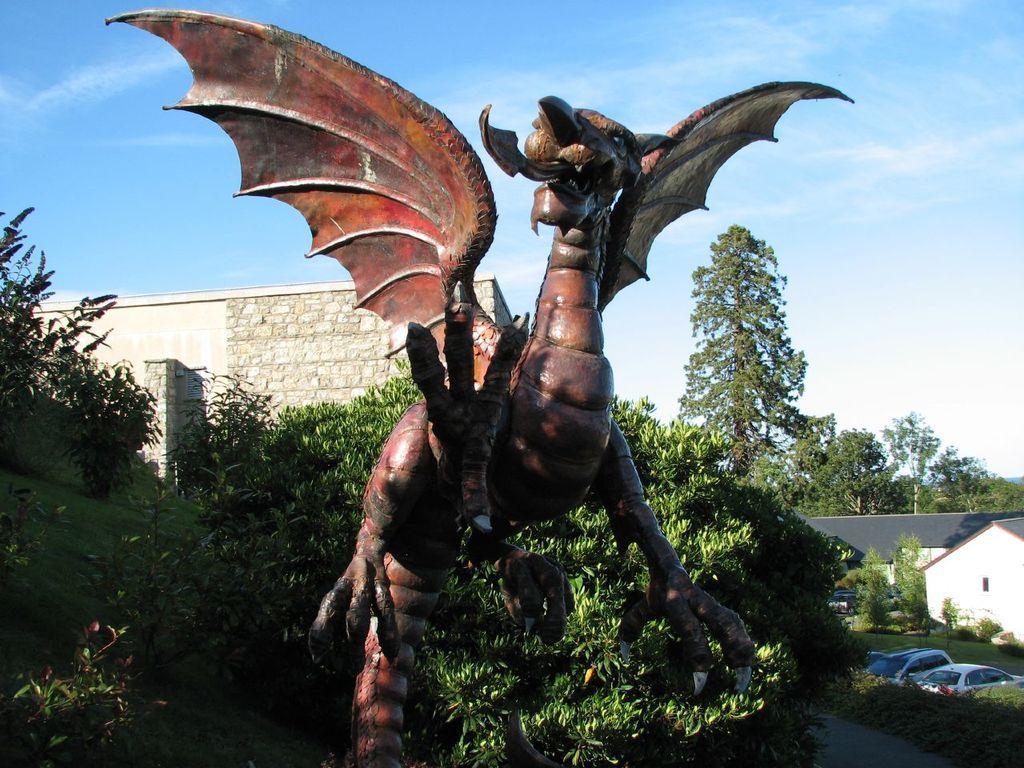Describe this image in one or two sentences. As we can see in the image there is an animal statue, plants, house, trees, cars and sky. 